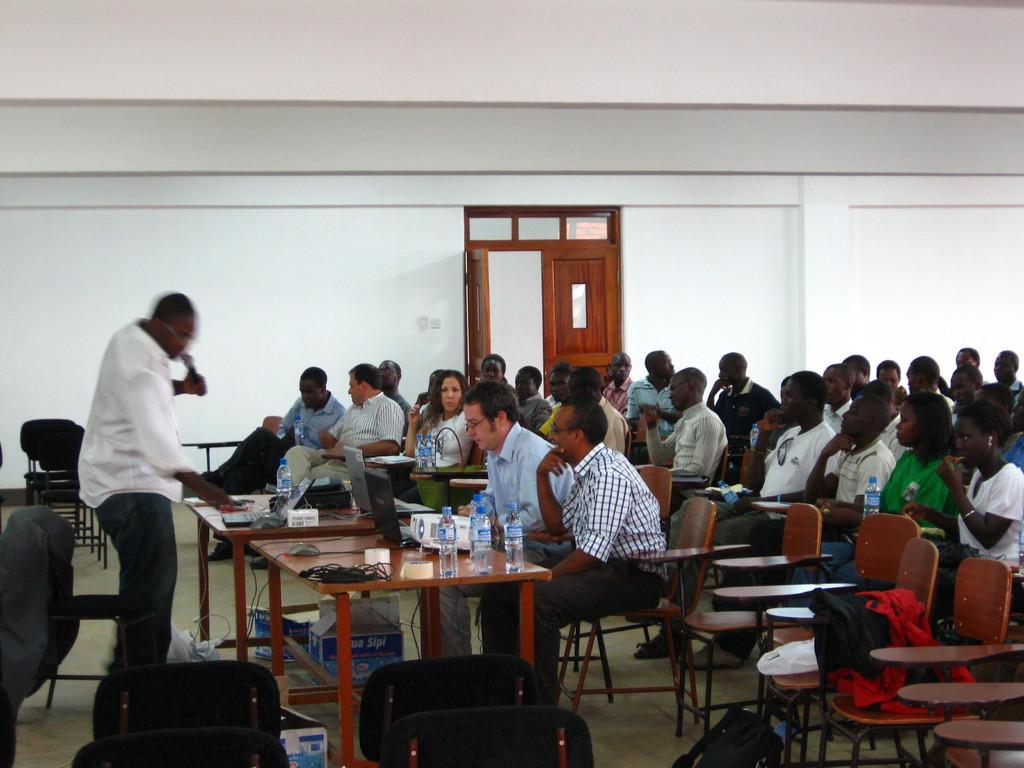Could you give a brief overview of what you see in this image? In this image there are group of people. There is a person with white shirt he is standing and holding a microphone. There are bottles, laptops, wires on the table. At the back there is a door. 